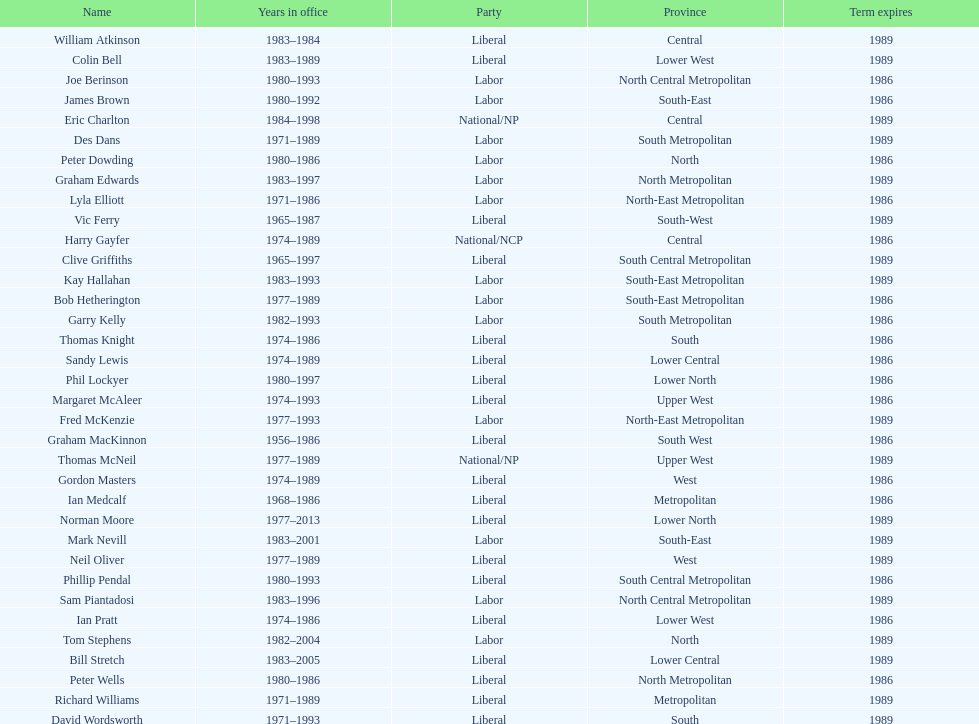What is the total number of members whose term expires in 1989? 9. 